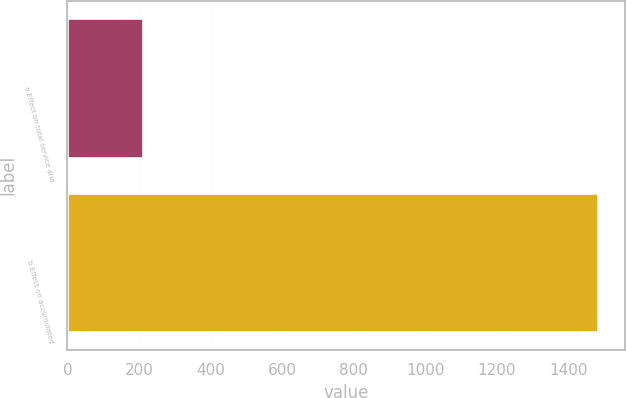<chart> <loc_0><loc_0><loc_500><loc_500><bar_chart><fcel>a Effect on total service and<fcel>b Effect on accumulated<nl><fcel>211<fcel>1483<nl></chart> 